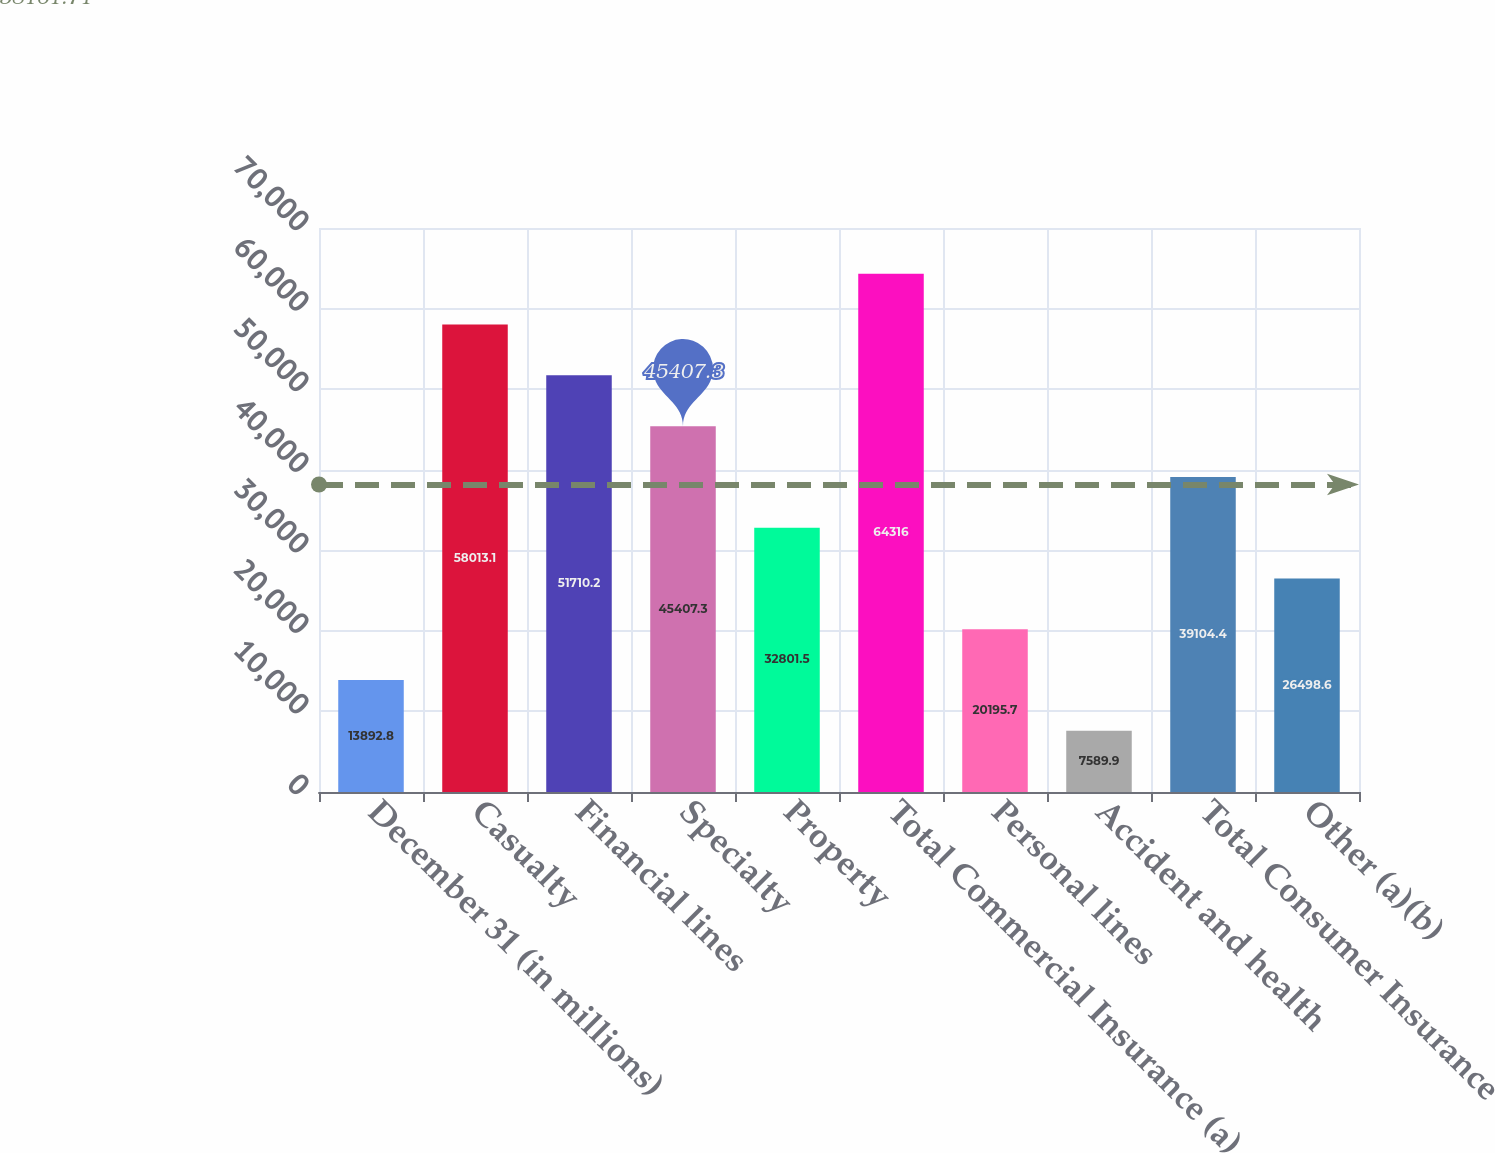Convert chart to OTSL. <chart><loc_0><loc_0><loc_500><loc_500><bar_chart><fcel>December 31 (in millions)<fcel>Casualty<fcel>Financial lines<fcel>Specialty<fcel>Property<fcel>Total Commercial Insurance (a)<fcel>Personal lines<fcel>Accident and health<fcel>Total Consumer Insurance<fcel>Other (a)(b)<nl><fcel>13892.8<fcel>58013.1<fcel>51710.2<fcel>45407.3<fcel>32801.5<fcel>64316<fcel>20195.7<fcel>7589.9<fcel>39104.4<fcel>26498.6<nl></chart> 